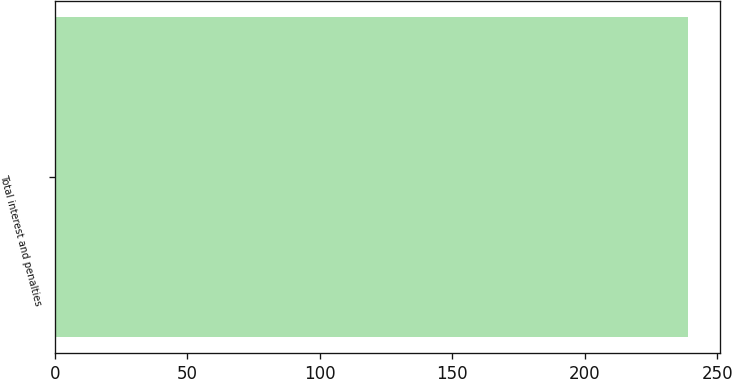Convert chart to OTSL. <chart><loc_0><loc_0><loc_500><loc_500><bar_chart><fcel>Total interest and penalties<nl><fcel>239<nl></chart> 